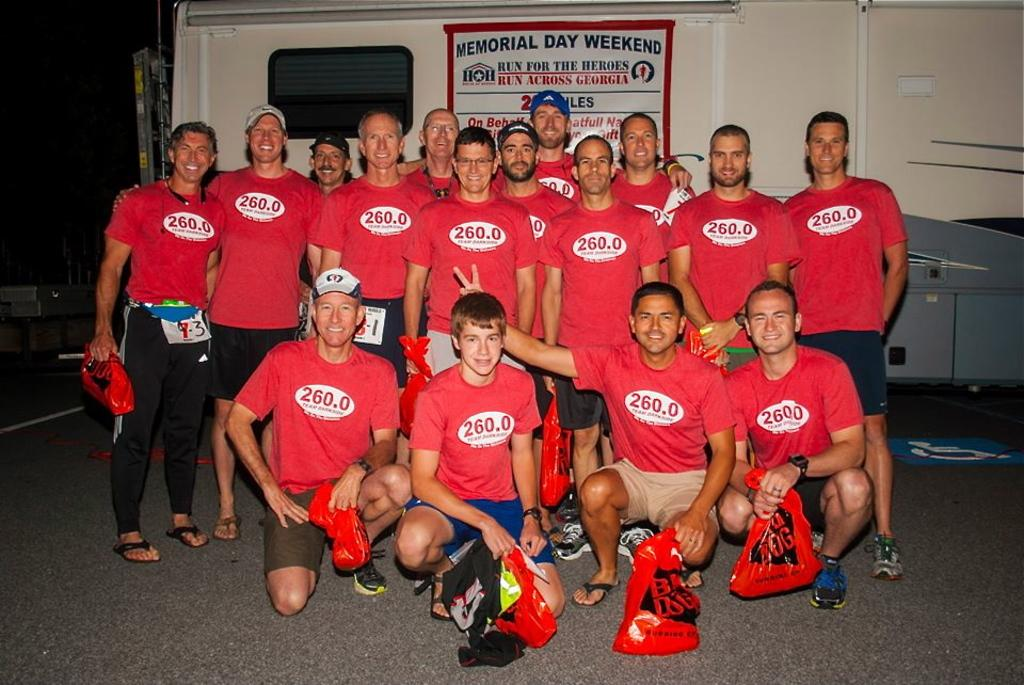Provide a one-sentence caption for the provided image. A large group of men all wearing the same top with 260.0 on them pose for a photo below a sign saying run for the heroes. 